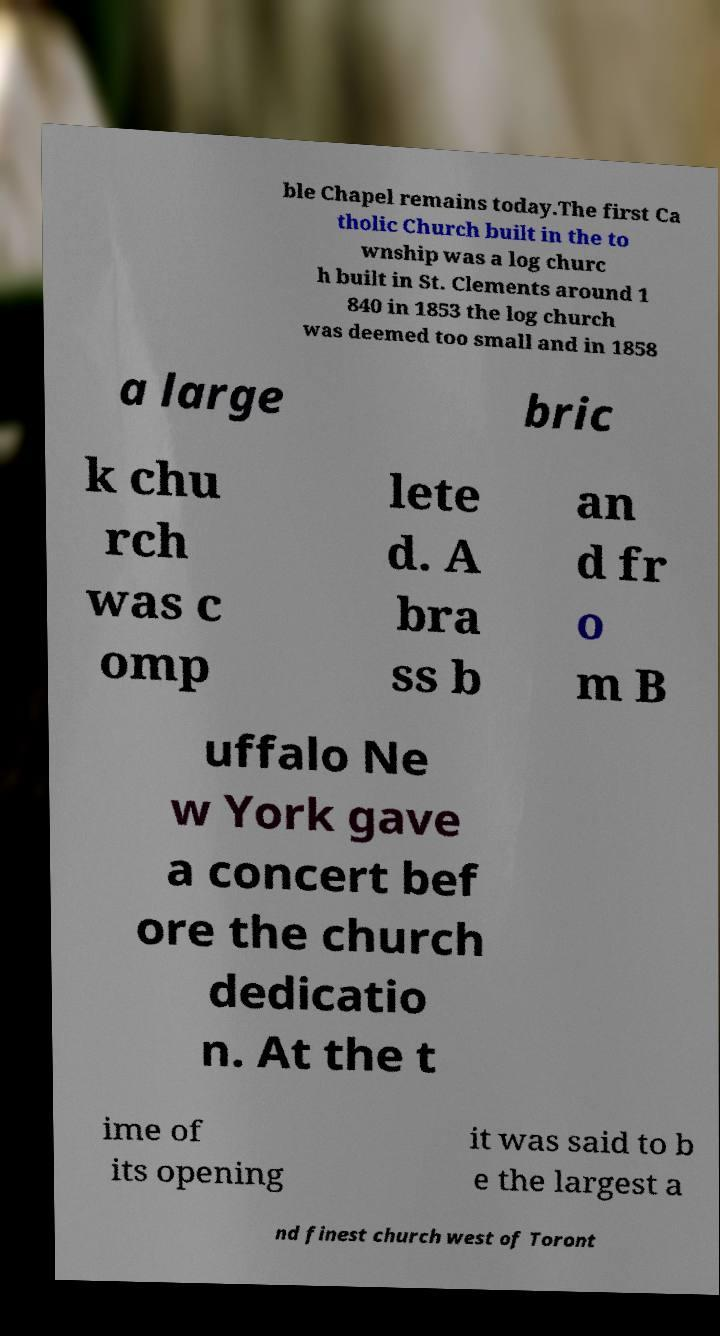Can you accurately transcribe the text from the provided image for me? ble Chapel remains today.The first Ca tholic Church built in the to wnship was a log churc h built in St. Clements around 1 840 in 1853 the log church was deemed too small and in 1858 a large bric k chu rch was c omp lete d. A bra ss b an d fr o m B uffalo Ne w York gave a concert bef ore the church dedicatio n. At the t ime of its opening it was said to b e the largest a nd finest church west of Toront 